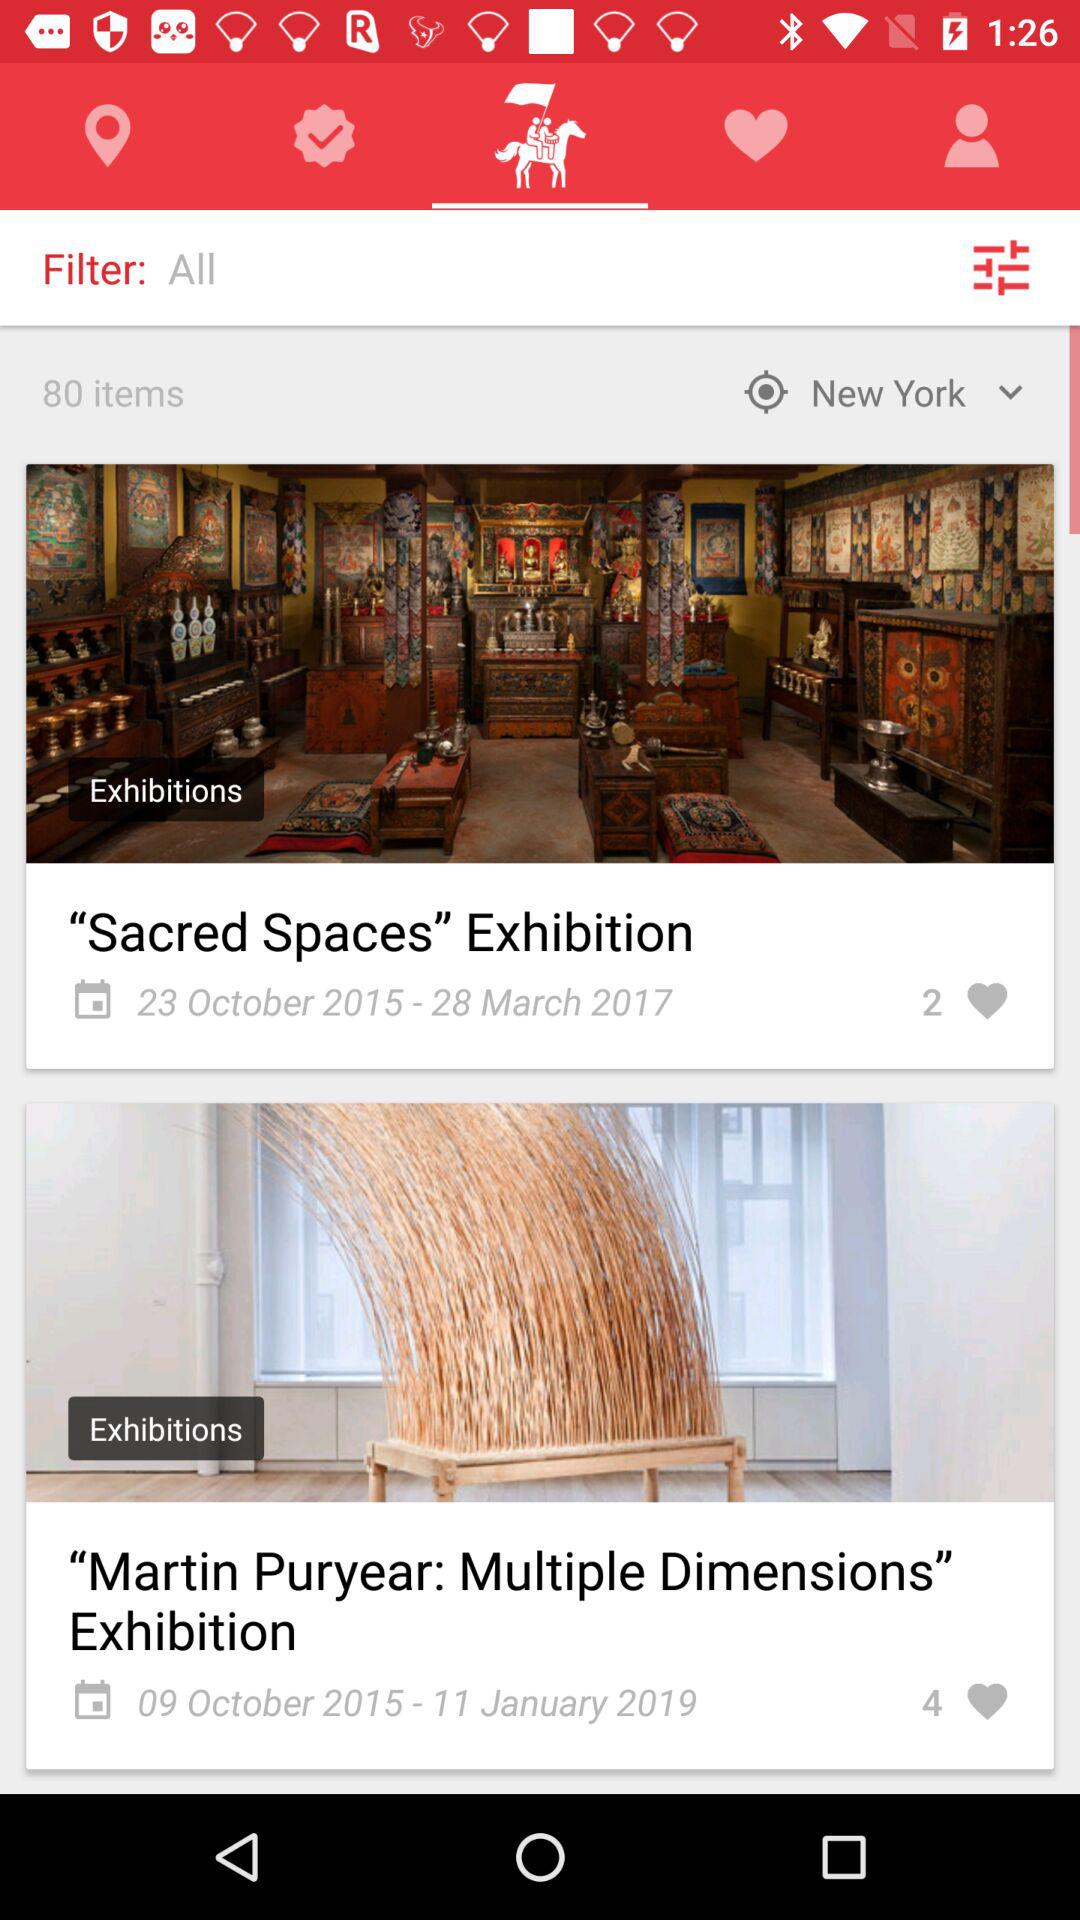Which location is selected? The selected location is New York. 